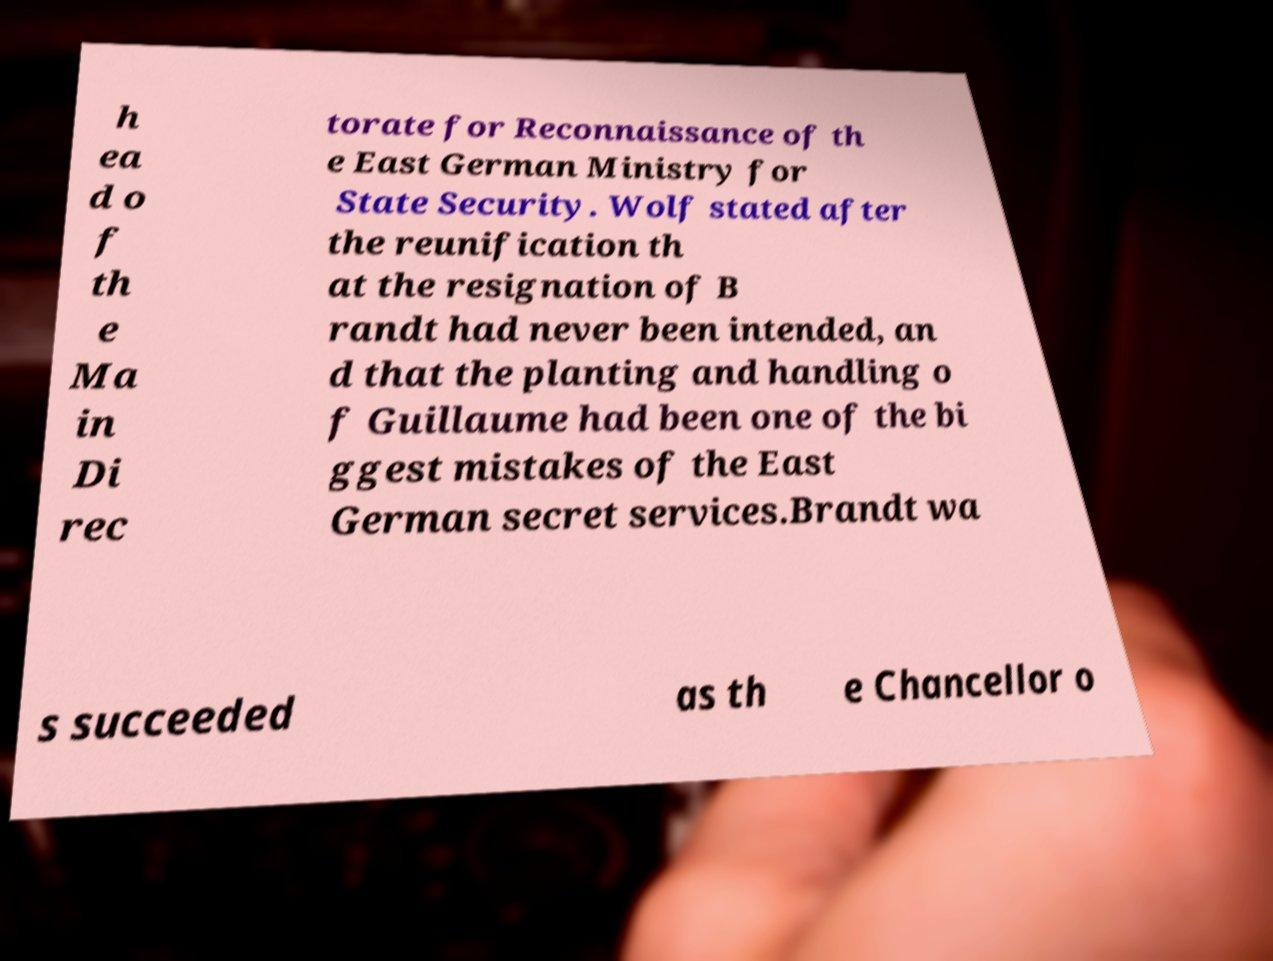There's text embedded in this image that I need extracted. Can you transcribe it verbatim? h ea d o f th e Ma in Di rec torate for Reconnaissance of th e East German Ministry for State Security. Wolf stated after the reunification th at the resignation of B randt had never been intended, an d that the planting and handling o f Guillaume had been one of the bi ggest mistakes of the East German secret services.Brandt wa s succeeded as th e Chancellor o 